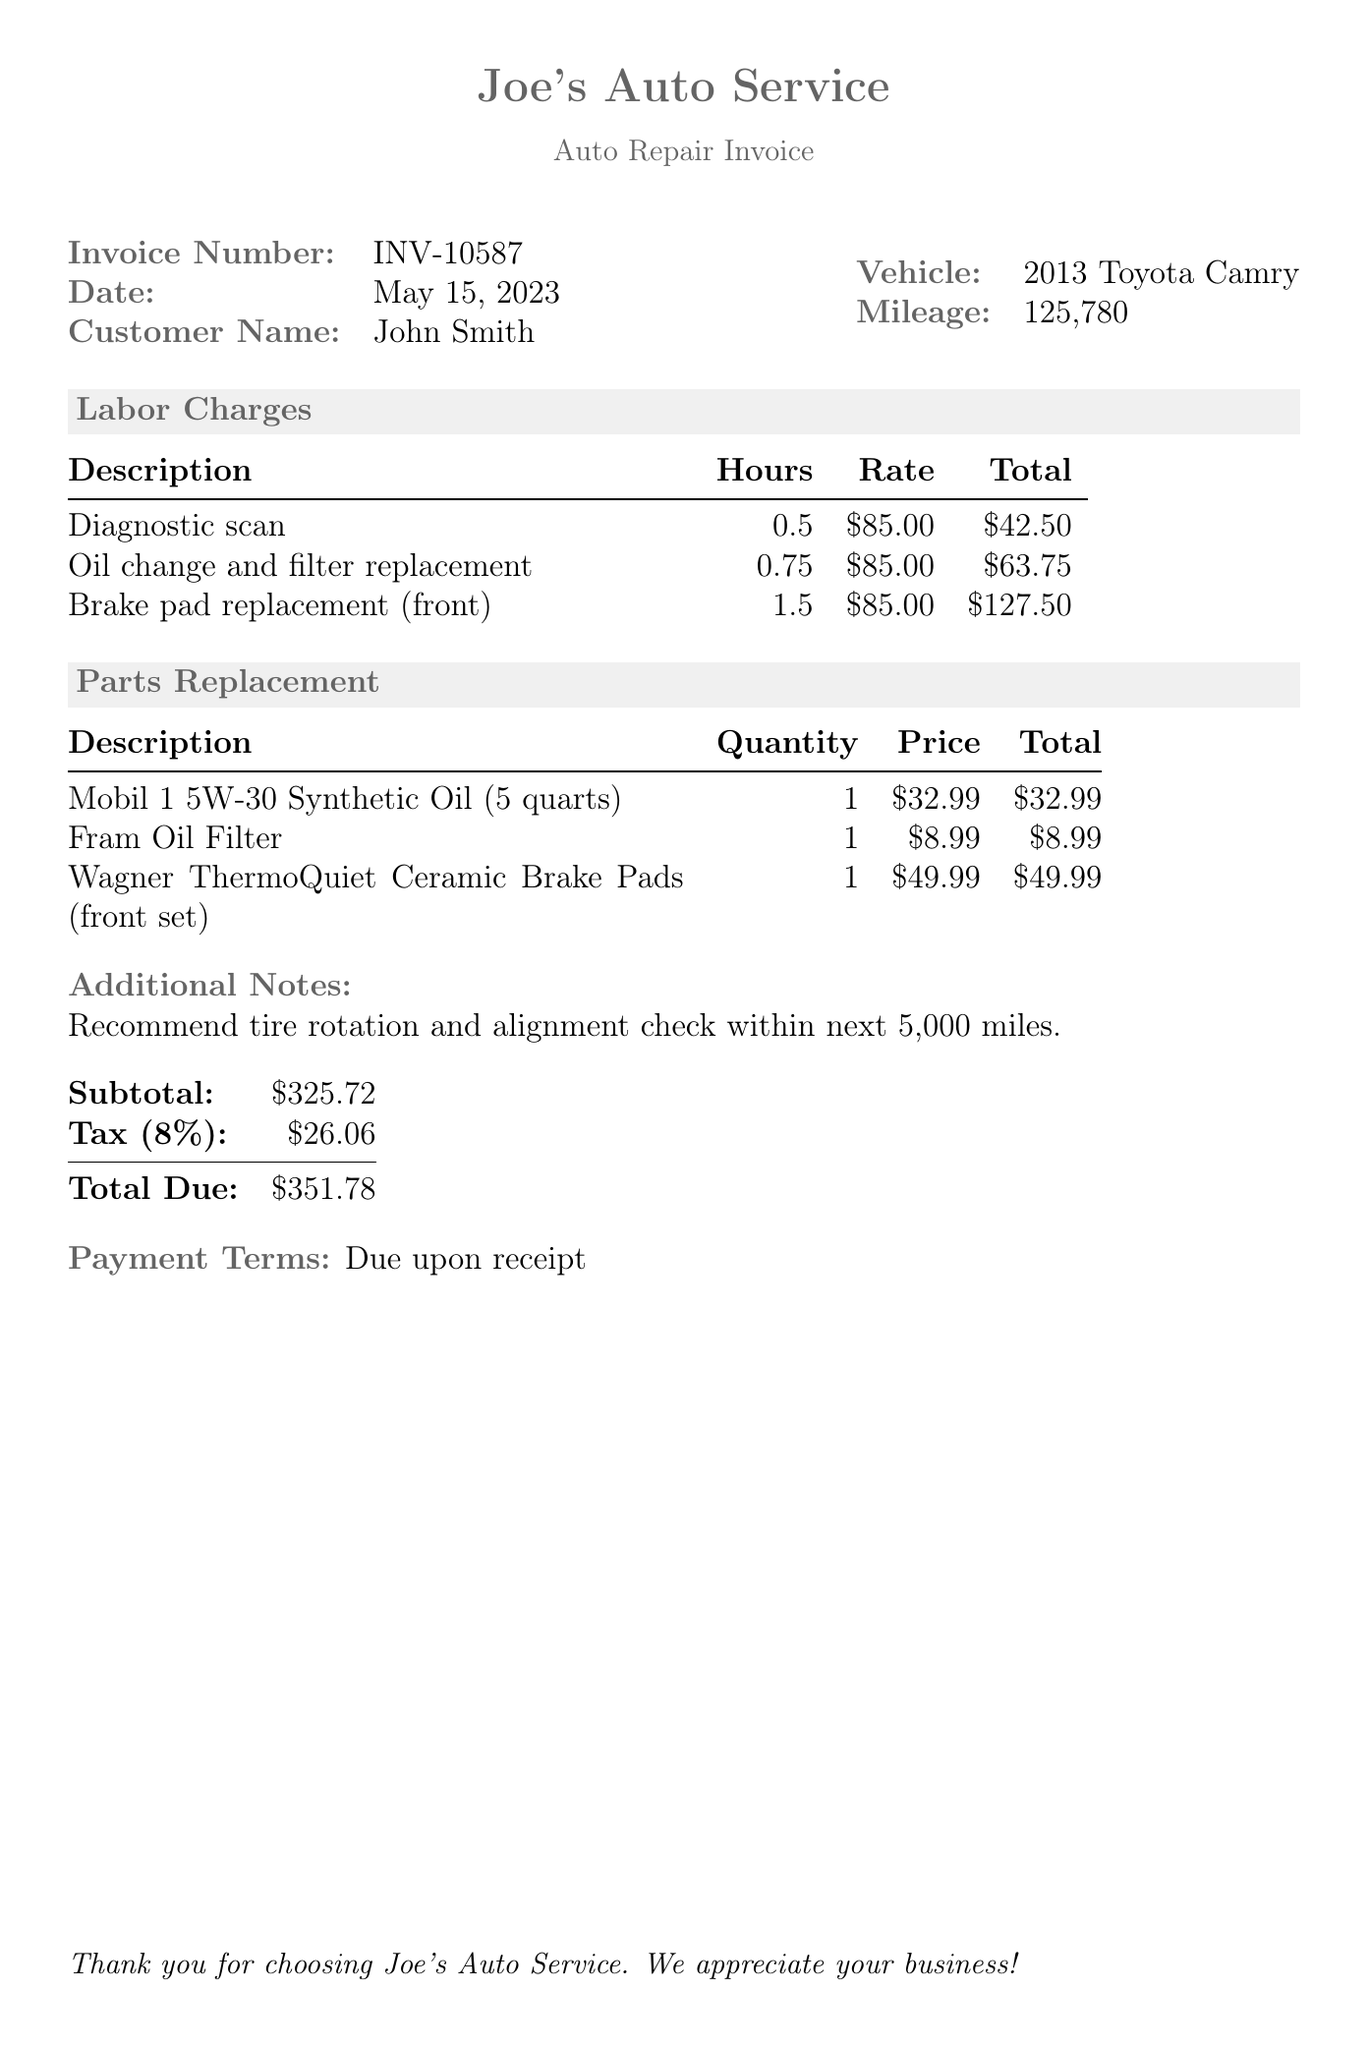what is the invoice number? The invoice number listed in the document is specified right at the top.
Answer: INV-10587 what is the date of the invoice? The date of the invoice is provided alongside the invoice number near the top of the document.
Answer: May 15, 2023 who is the customer? The customer name is stated clearly in the invoice section of the document.
Answer: John Smith what is the total due amount? The total due is calculated at the bottom of the invoice after including subtotals and tax.
Answer: $351.78 how many hours were billed for the brake pad replacement? The hours billed for the brake pad replacement is found in the labor charges section.
Answer: 1.5 what type of oil was used? The type of oil is listed in the parts replacement section of the document.
Answer: Mobil 1 5W-30 Synthetic Oil what is the tax percentage applied? The tax percentage is included in the totals calculation section and is standard information for invoices.
Answer: 8% what is the subtotal before tax? The subtotal is provided right before the tax amount at the bottom of the invoice.
Answer: $325.72 what additional service is recommended? The recommended service is stated in the additional notes section of the document.
Answer: Tire rotation and alignment check 